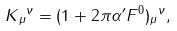Convert formula to latex. <formula><loc_0><loc_0><loc_500><loc_500>K { _ { \mu } } ^ { \nu } = ( 1 + 2 \pi \alpha ^ { \prime } F ^ { 0 } ) { _ { \mu } } ^ { \nu } ,</formula> 